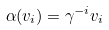Convert formula to latex. <formula><loc_0><loc_0><loc_500><loc_500>\alpha ( v _ { i } ) = \gamma ^ { - i } v _ { i }</formula> 